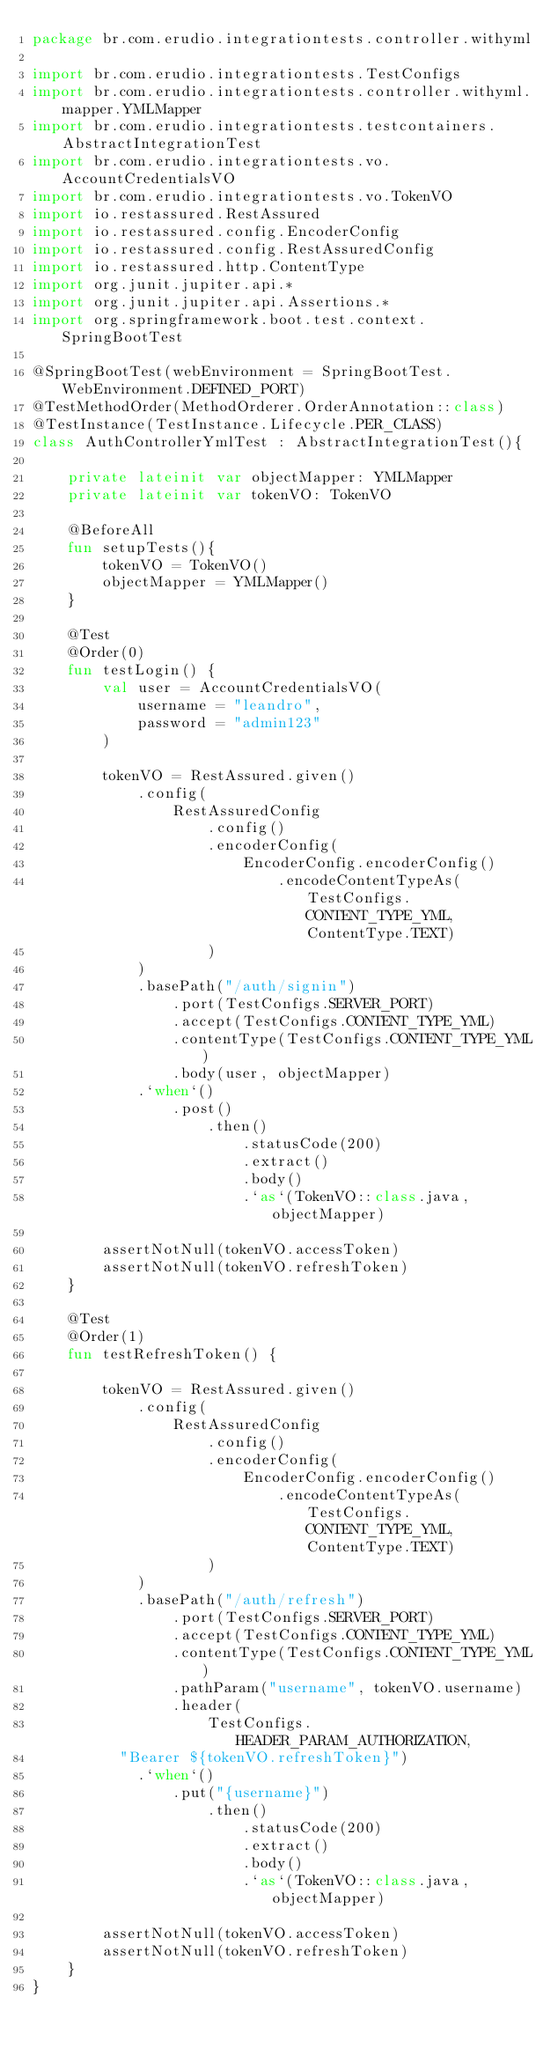Convert code to text. <code><loc_0><loc_0><loc_500><loc_500><_Kotlin_>package br.com.erudio.integrationtests.controller.withyml

import br.com.erudio.integrationtests.TestConfigs
import br.com.erudio.integrationtests.controller.withyml.mapper.YMLMapper
import br.com.erudio.integrationtests.testcontainers.AbstractIntegrationTest
import br.com.erudio.integrationtests.vo.AccountCredentialsVO
import br.com.erudio.integrationtests.vo.TokenVO
import io.restassured.RestAssured
import io.restassured.config.EncoderConfig
import io.restassured.config.RestAssuredConfig
import io.restassured.http.ContentType
import org.junit.jupiter.api.*
import org.junit.jupiter.api.Assertions.*
import org.springframework.boot.test.context.SpringBootTest

@SpringBootTest(webEnvironment = SpringBootTest.WebEnvironment.DEFINED_PORT)
@TestMethodOrder(MethodOrderer.OrderAnnotation::class)
@TestInstance(TestInstance.Lifecycle.PER_CLASS)
class AuthControllerYmlTest : AbstractIntegrationTest(){

    private lateinit var objectMapper: YMLMapper
    private lateinit var tokenVO: TokenVO

    @BeforeAll
    fun setupTests(){
        tokenVO = TokenVO()
        objectMapper = YMLMapper()
    }

    @Test
    @Order(0)
    fun testLogin() {
        val user = AccountCredentialsVO(
            username = "leandro",
            password = "admin123"
        )

        tokenVO = RestAssured.given()
            .config(
                RestAssuredConfig
                    .config()
                    .encoderConfig(
                        EncoderConfig.encoderConfig()
                            .encodeContentTypeAs(TestConfigs.CONTENT_TYPE_YML, ContentType.TEXT)
                    )
            )
            .basePath("/auth/signin")
                .port(TestConfigs.SERVER_PORT)
                .accept(TestConfigs.CONTENT_TYPE_YML)
                .contentType(TestConfigs.CONTENT_TYPE_YML)
                .body(user, objectMapper)
            .`when`()
                .post()
                    .then()
                        .statusCode(200)
                        .extract()
                        .body()
                        .`as`(TokenVO::class.java, objectMapper)

        assertNotNull(tokenVO.accessToken)
        assertNotNull(tokenVO.refreshToken)
    }

    @Test
    @Order(1)
    fun testRefreshToken() {

        tokenVO = RestAssured.given()
            .config(
                RestAssuredConfig
                    .config()
                    .encoderConfig(
                        EncoderConfig.encoderConfig()
                            .encodeContentTypeAs(TestConfigs.CONTENT_TYPE_YML, ContentType.TEXT)
                    )
            )
            .basePath("/auth/refresh")
                .port(TestConfigs.SERVER_PORT)
                .accept(TestConfigs.CONTENT_TYPE_YML)
                .contentType(TestConfigs.CONTENT_TYPE_YML)
                .pathParam("username", tokenVO.username)
                .header(
                    TestConfigs.HEADER_PARAM_AUTHORIZATION,
          "Bearer ${tokenVO.refreshToken}")
            .`when`()
                .put("{username}")
                    .then()
                        .statusCode(200)
                        .extract()
                        .body()
                        .`as`(TokenVO::class.java, objectMapper)

        assertNotNull(tokenVO.accessToken)
        assertNotNull(tokenVO.refreshToken)
    }
}</code> 